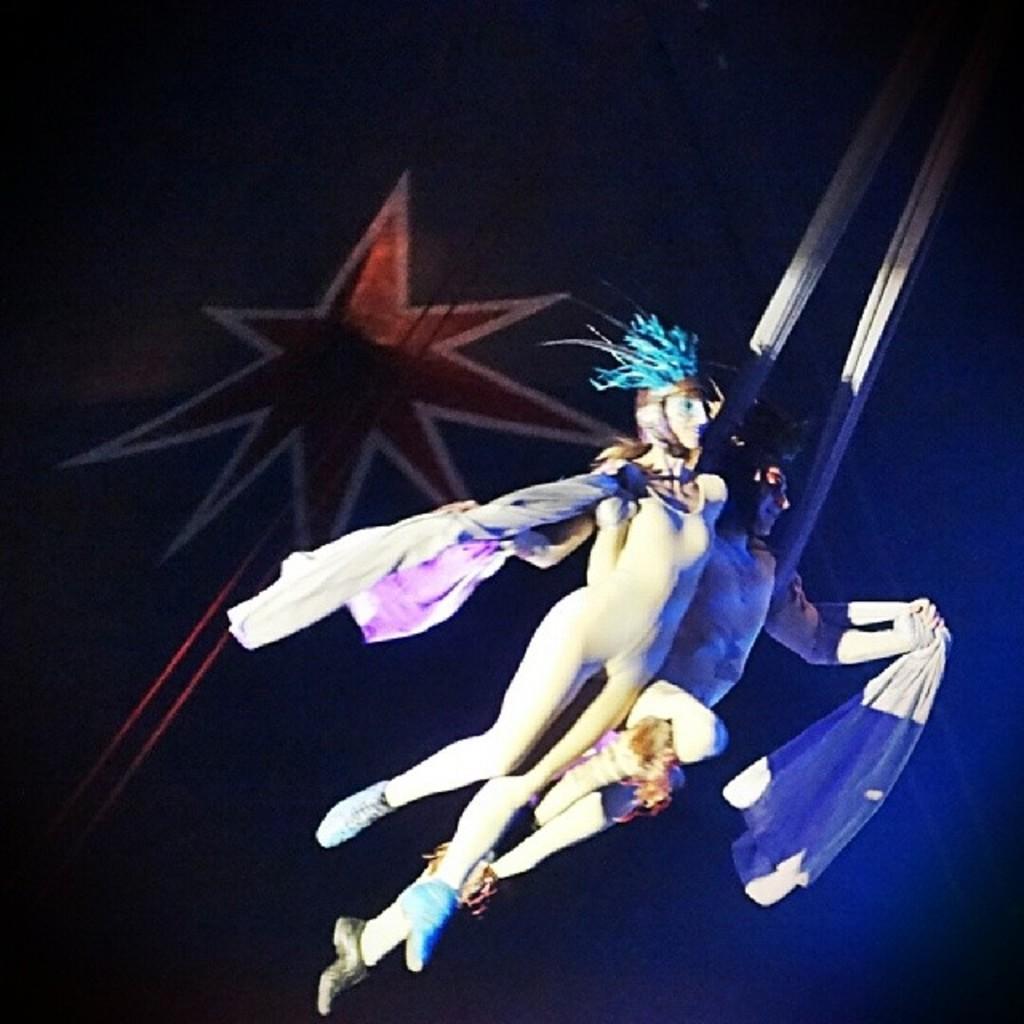Please provide a concise description of this image. In this image we can see two persons wearing costumes and holding cloth in their hands. In the background, we can see some ropes and a painting on the wall. 